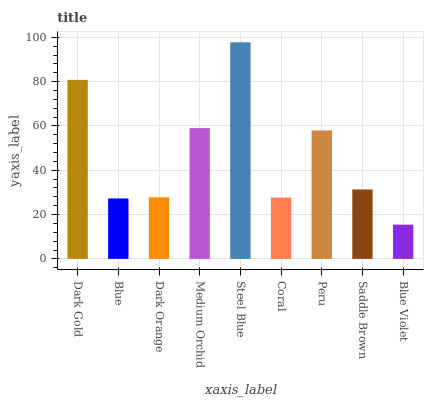Is Blue Violet the minimum?
Answer yes or no. Yes. Is Steel Blue the maximum?
Answer yes or no. Yes. Is Blue the minimum?
Answer yes or no. No. Is Blue the maximum?
Answer yes or no. No. Is Dark Gold greater than Blue?
Answer yes or no. Yes. Is Blue less than Dark Gold?
Answer yes or no. Yes. Is Blue greater than Dark Gold?
Answer yes or no. No. Is Dark Gold less than Blue?
Answer yes or no. No. Is Saddle Brown the high median?
Answer yes or no. Yes. Is Saddle Brown the low median?
Answer yes or no. Yes. Is Steel Blue the high median?
Answer yes or no. No. Is Medium Orchid the low median?
Answer yes or no. No. 